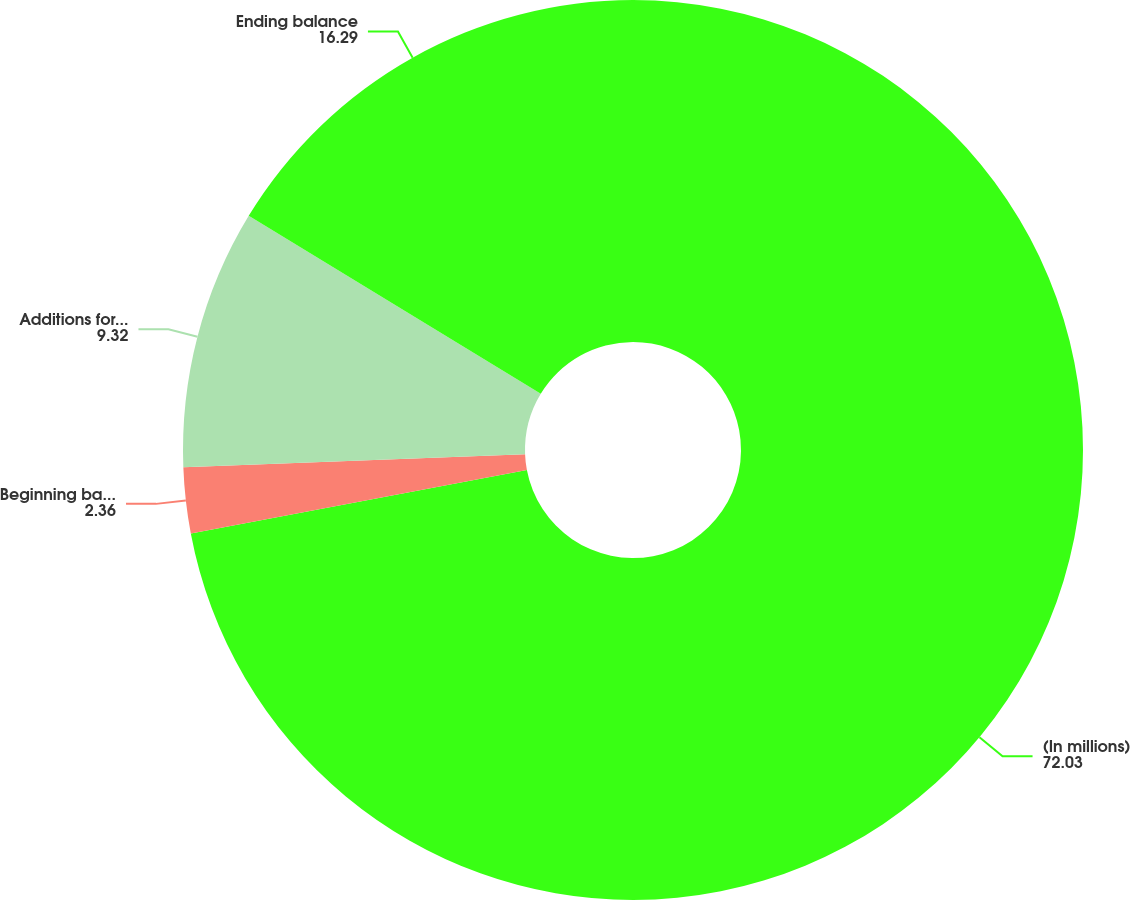Convert chart to OTSL. <chart><loc_0><loc_0><loc_500><loc_500><pie_chart><fcel>(In millions)<fcel>Beginning balance<fcel>Additions for tax positions of<fcel>Ending balance<nl><fcel>72.03%<fcel>2.36%<fcel>9.32%<fcel>16.29%<nl></chart> 